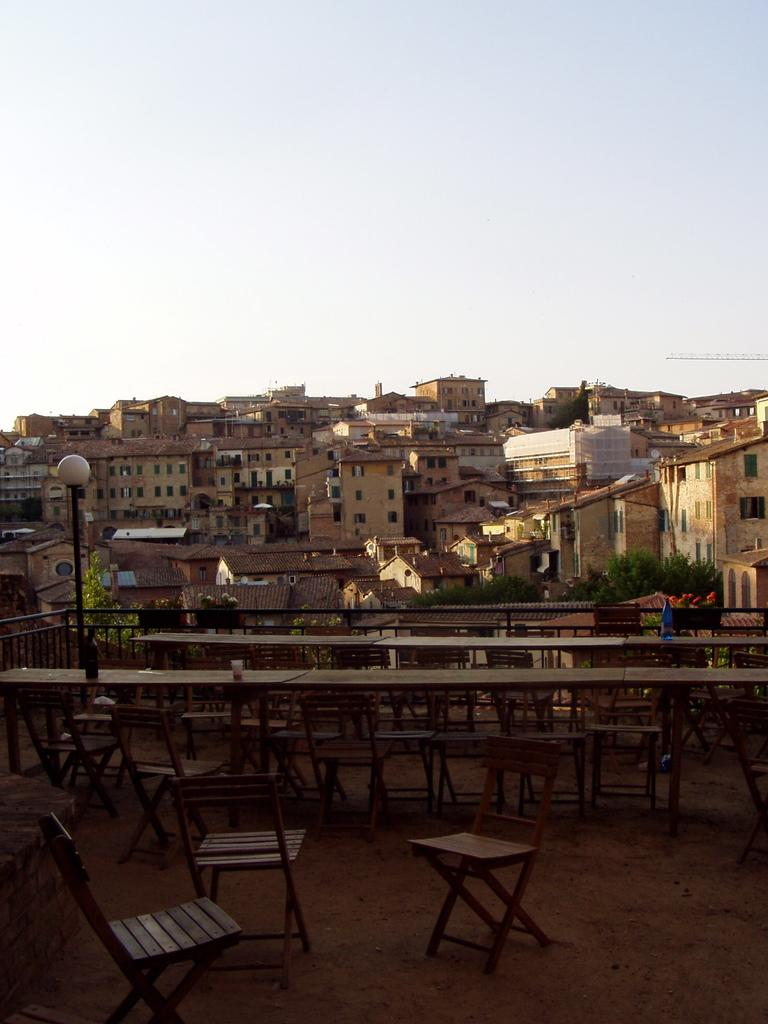What type of furniture is visible in the image? There are chairs and tables in the image. What material is used for the rods in the image? Metal rods are present in the image. What can be used for illumination in the image? There is a light in the image. What is visible in the background of the image? There are buildings and trees in the background of the image. What type of current can be seen flowing through the trees in the image? There is no current flowing through the trees in the image; it is a still image. What type of insect is sitting on the light in the image? There are no insects present in the image. 